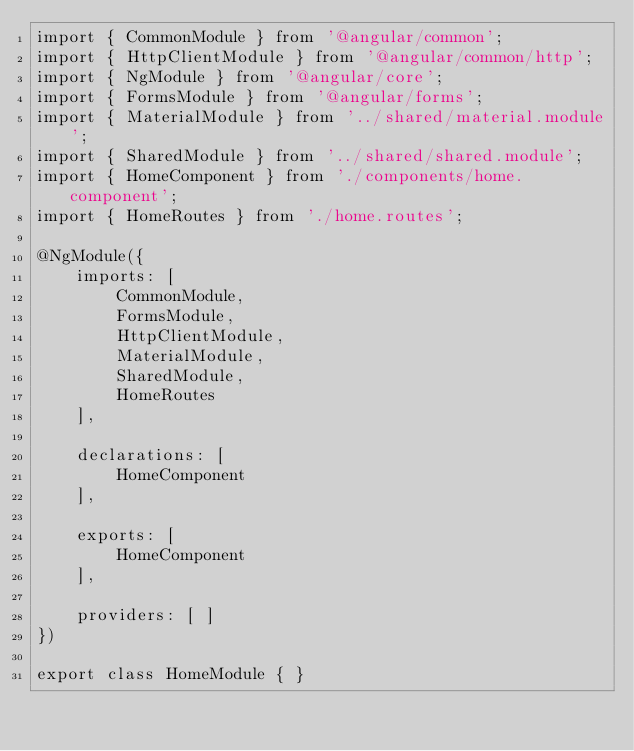<code> <loc_0><loc_0><loc_500><loc_500><_TypeScript_>import { CommonModule } from '@angular/common';
import { HttpClientModule } from '@angular/common/http';
import { NgModule } from '@angular/core';
import { FormsModule } from '@angular/forms';
import { MaterialModule } from '../shared/material.module';
import { SharedModule } from '../shared/shared.module';
import { HomeComponent } from './components/home.component';
import { HomeRoutes } from './home.routes';

@NgModule({
    imports: [
        CommonModule,
        FormsModule,
        HttpClientModule,
        MaterialModule,
        SharedModule,
        HomeRoutes
    ],

    declarations: [
        HomeComponent
    ],

    exports: [
        HomeComponent
    ],

    providers: [ ]
})

export class HomeModule { }</code> 